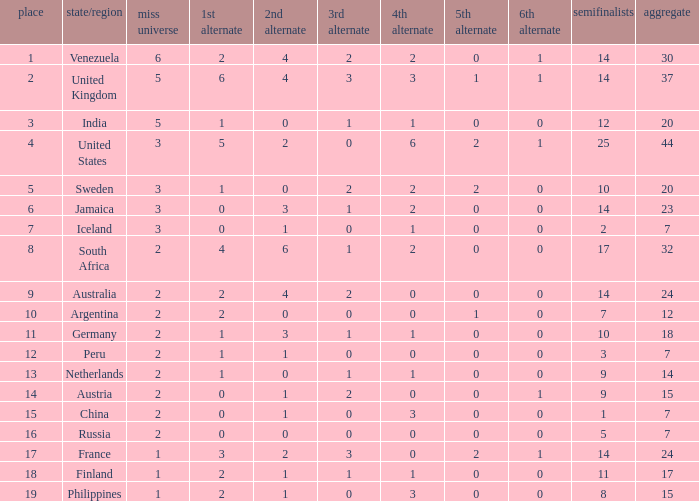What is Venezuela's total rank? 30.0. 